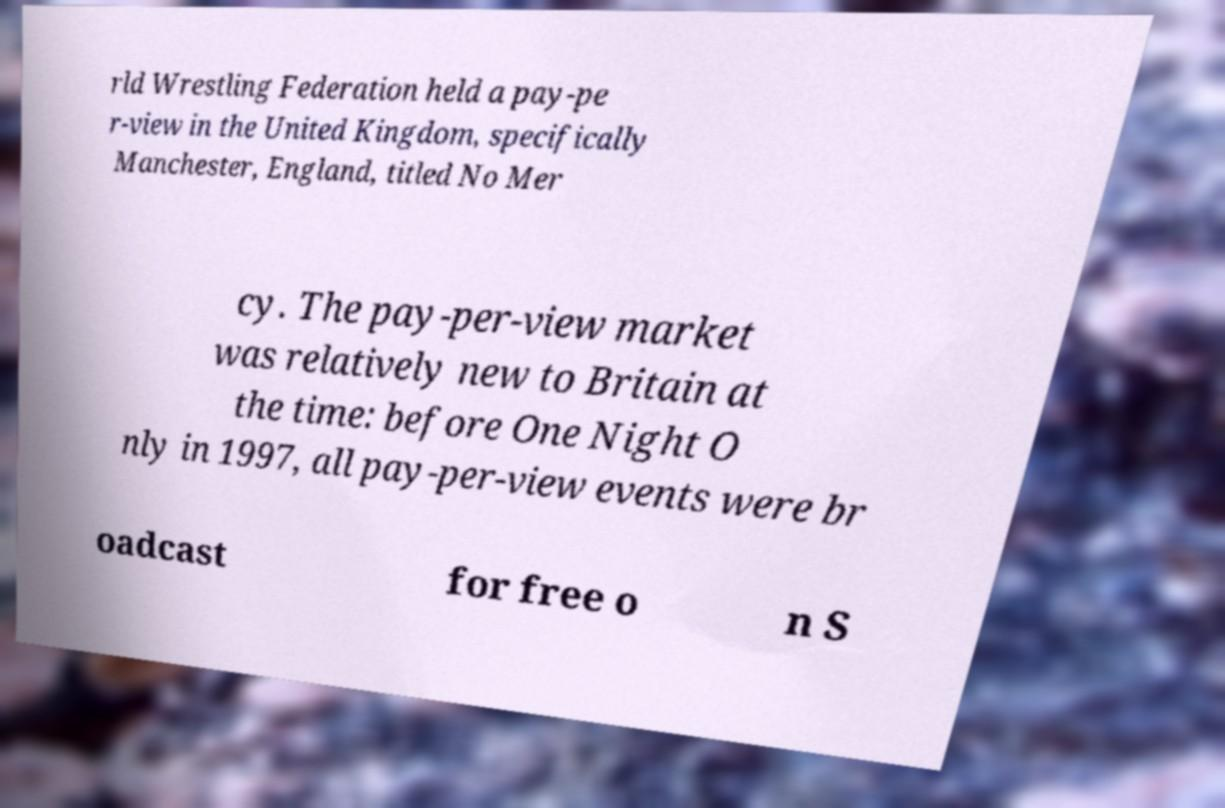Can you accurately transcribe the text from the provided image for me? rld Wrestling Federation held a pay-pe r-view in the United Kingdom, specifically Manchester, England, titled No Mer cy. The pay-per-view market was relatively new to Britain at the time: before One Night O nly in 1997, all pay-per-view events were br oadcast for free o n S 